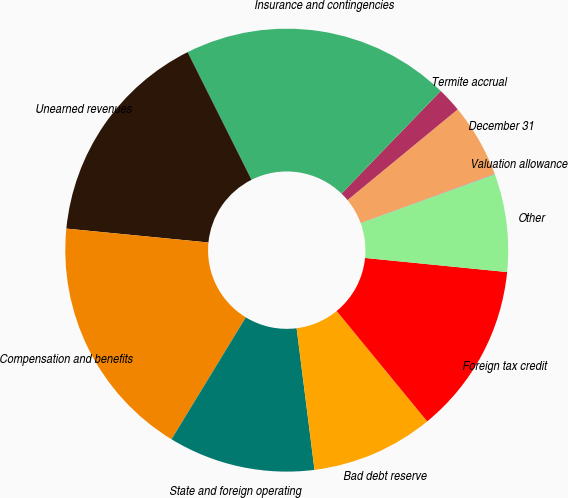<chart> <loc_0><loc_0><loc_500><loc_500><pie_chart><fcel>December 31<fcel>Termite accrual<fcel>Insurance and contingencies<fcel>Unearned revenues<fcel>Compensation and benefits<fcel>State and foreign operating<fcel>Bad debt reserve<fcel>Foreign tax credit<fcel>Other<fcel>Valuation allowance<nl><fcel>5.37%<fcel>1.8%<fcel>19.62%<fcel>16.06%<fcel>17.84%<fcel>10.71%<fcel>8.93%<fcel>12.49%<fcel>7.15%<fcel>0.02%<nl></chart> 